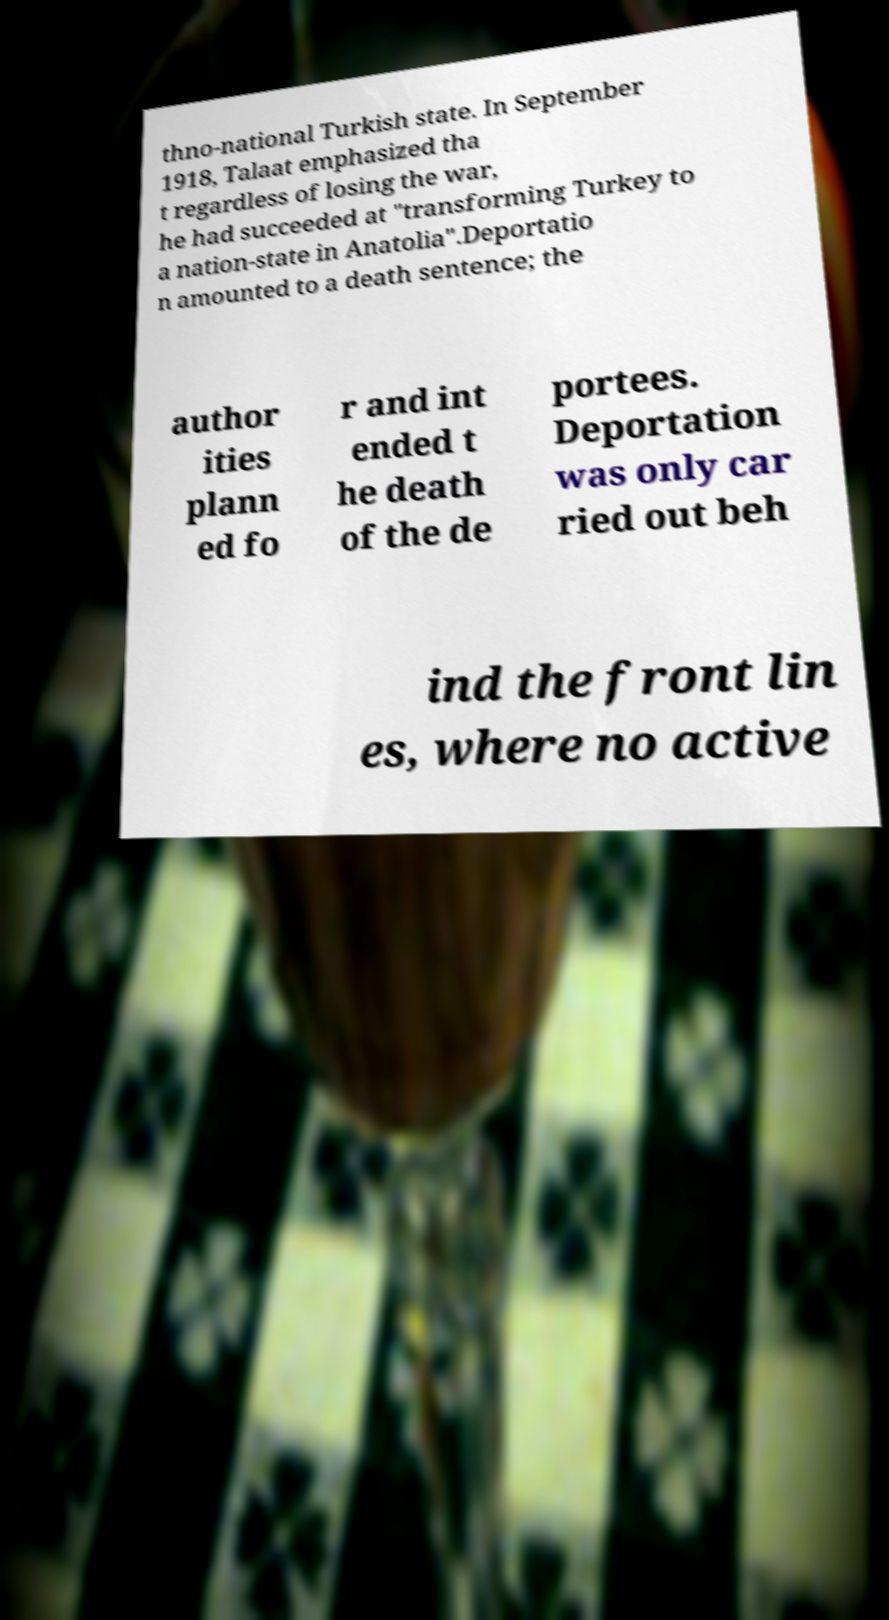Can you accurately transcribe the text from the provided image for me? thno-national Turkish state. In September 1918, Talaat emphasized tha t regardless of losing the war, he had succeeded at "transforming Turkey to a nation-state in Anatolia".Deportatio n amounted to a death sentence; the author ities plann ed fo r and int ended t he death of the de portees. Deportation was only car ried out beh ind the front lin es, where no active 